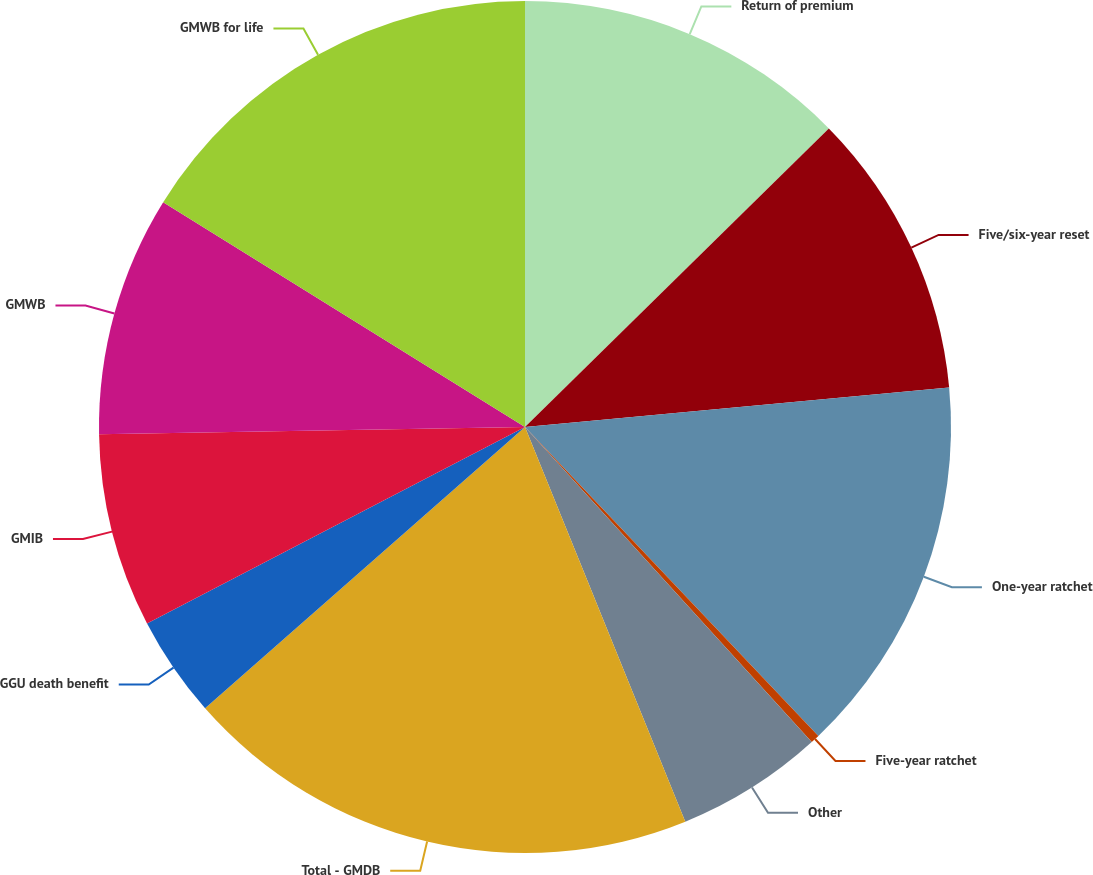Convert chart to OTSL. <chart><loc_0><loc_0><loc_500><loc_500><pie_chart><fcel>Return of premium<fcel>Five/six-year reset<fcel>One-year ratchet<fcel>Five-year ratchet<fcel>Other<fcel>Total - GMDB<fcel>GGU death benefit<fcel>GMIB<fcel>GMWB<fcel>GMWB for life<nl><fcel>12.64%<fcel>10.88%<fcel>14.39%<fcel>0.34%<fcel>5.61%<fcel>19.66%<fcel>3.85%<fcel>7.36%<fcel>9.12%<fcel>16.15%<nl></chart> 